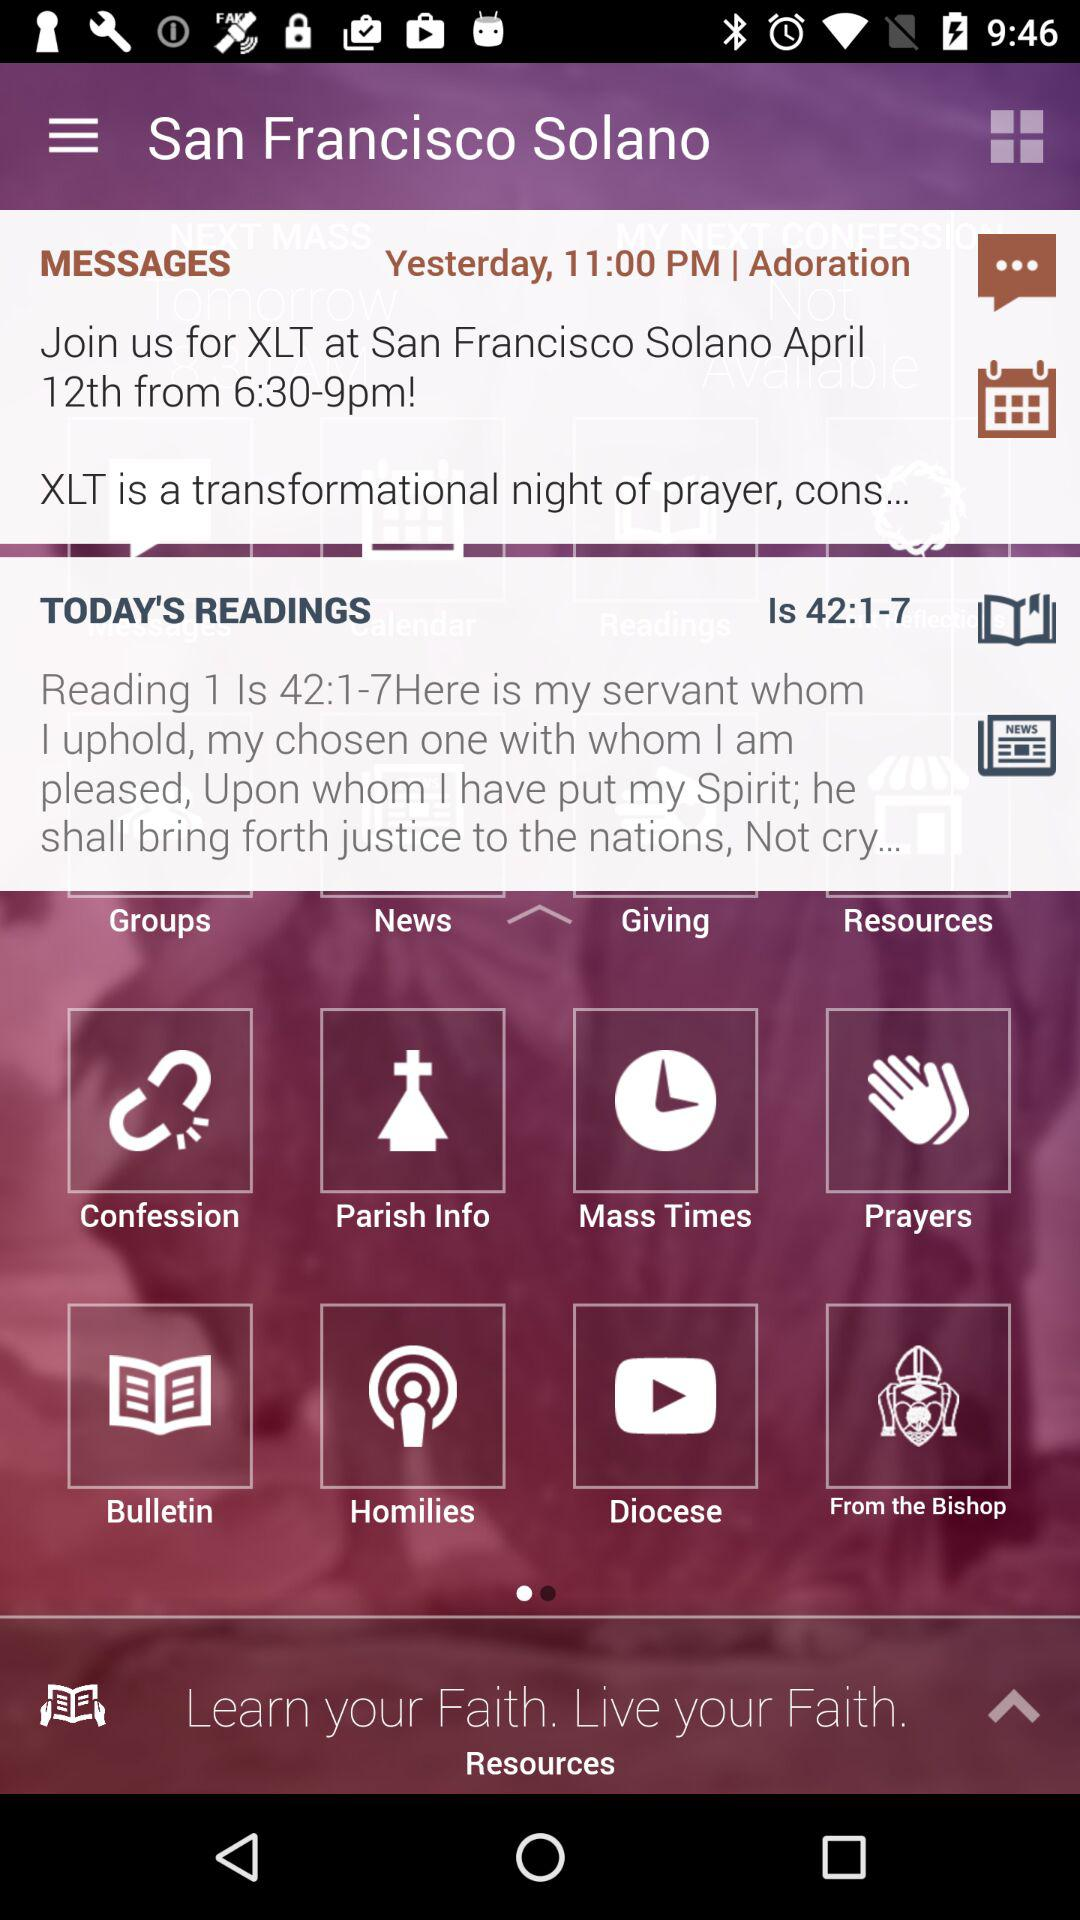How many more messages are there than today's readings?
Answer the question using a single word or phrase. 1 